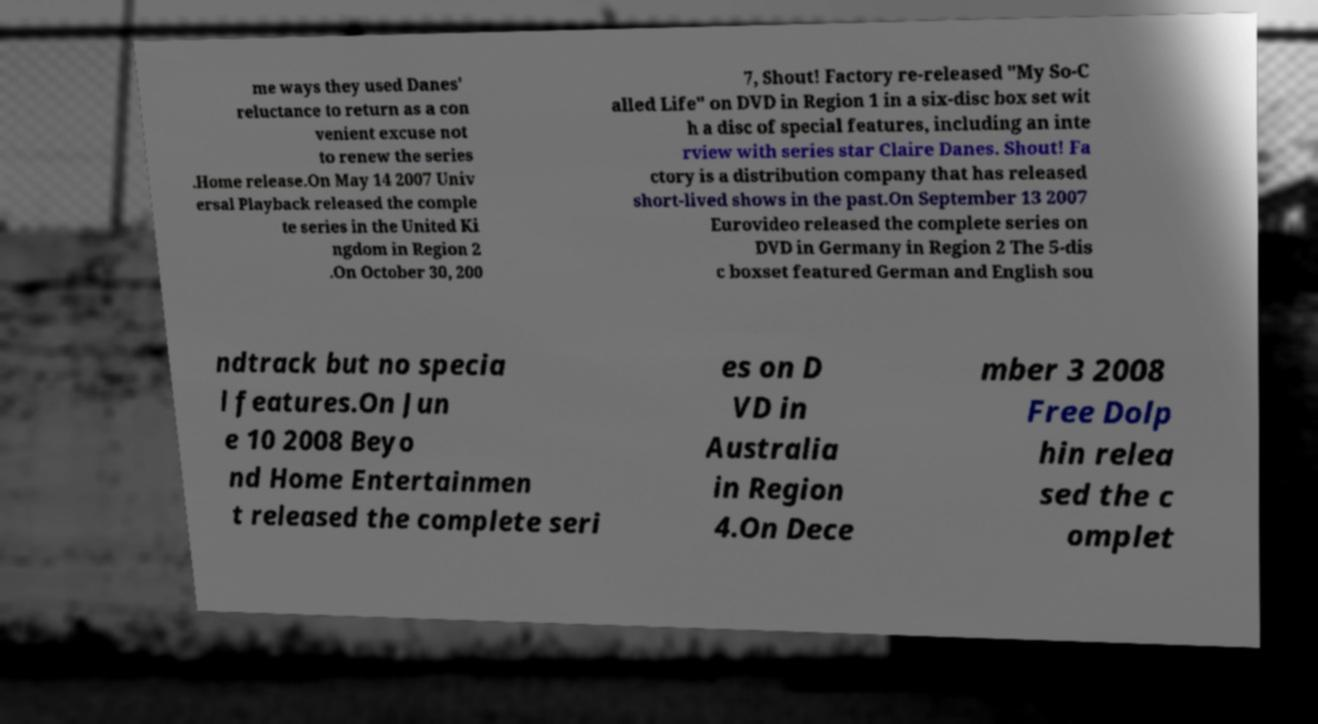Can you accurately transcribe the text from the provided image for me? me ways they used Danes' reluctance to return as a con venient excuse not to renew the series .Home release.On May 14 2007 Univ ersal Playback released the comple te series in the United Ki ngdom in Region 2 .On October 30, 200 7, Shout! Factory re-released "My So-C alled Life" on DVD in Region 1 in a six-disc box set wit h a disc of special features, including an inte rview with series star Claire Danes. Shout! Fa ctory is a distribution company that has released short-lived shows in the past.On September 13 2007 Eurovideo released the complete series on DVD in Germany in Region 2 The 5-dis c boxset featured German and English sou ndtrack but no specia l features.On Jun e 10 2008 Beyo nd Home Entertainmen t released the complete seri es on D VD in Australia in Region 4.On Dece mber 3 2008 Free Dolp hin relea sed the c omplet 